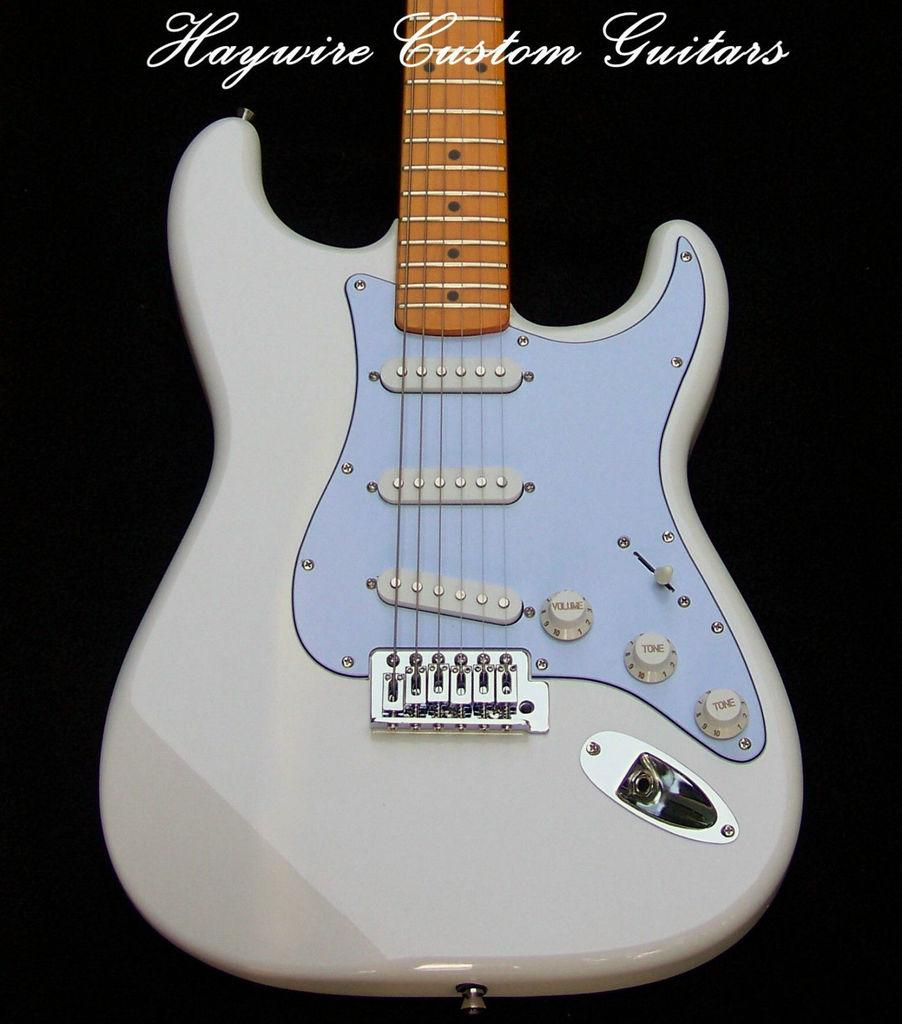What musical instrument is present in the image? There is a guitar in the image. What color is the guitar? The guitar is white in color. What part of the guitar is yellow? The handle of the guitar is yellow. What color is the background of the image? The background of the image is black. What type of sand can be seen in the image? There is no sand present in the image. What kind of thing is the guitar serving in the image? The guitar is not serving any purpose or thing in the image; it is simply a musical instrument. 